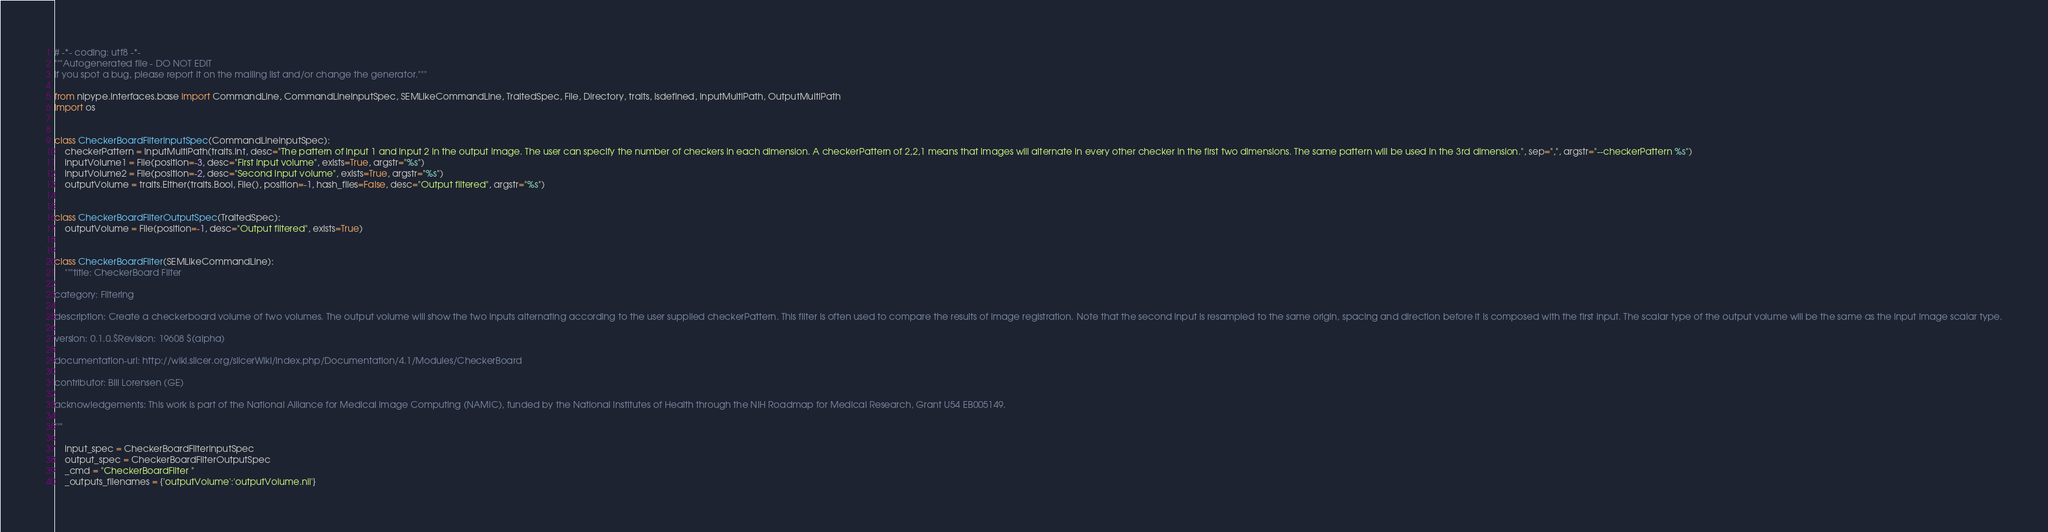<code> <loc_0><loc_0><loc_500><loc_500><_Python_># -*- coding: utf8 -*-
"""Autogenerated file - DO NOT EDIT
If you spot a bug, please report it on the mailing list and/or change the generator."""

from nipype.interfaces.base import CommandLine, CommandLineInputSpec, SEMLikeCommandLine, TraitedSpec, File, Directory, traits, isdefined, InputMultiPath, OutputMultiPath
import os


class CheckerBoardFilterInputSpec(CommandLineInputSpec):
    checkerPattern = InputMultiPath(traits.Int, desc="The pattern of input 1 and input 2 in the output image. The user can specify the number of checkers in each dimension. A checkerPattern of 2,2,1 means that images will alternate in every other checker in the first two dimensions. The same pattern will be used in the 3rd dimension.", sep=",", argstr="--checkerPattern %s")
    inputVolume1 = File(position=-3, desc="First Input volume", exists=True, argstr="%s")
    inputVolume2 = File(position=-2, desc="Second Input volume", exists=True, argstr="%s")
    outputVolume = traits.Either(traits.Bool, File(), position=-1, hash_files=False, desc="Output filtered", argstr="%s")


class CheckerBoardFilterOutputSpec(TraitedSpec):
    outputVolume = File(position=-1, desc="Output filtered", exists=True)


class CheckerBoardFilter(SEMLikeCommandLine):
    """title: CheckerBoard Filter

category: Filtering

description: Create a checkerboard volume of two volumes. The output volume will show the two inputs alternating according to the user supplied checkerPattern. This filter is often used to compare the results of image registration. Note that the second input is resampled to the same origin, spacing and direction before it is composed with the first input. The scalar type of the output volume will be the same as the input image scalar type.

version: 0.1.0.$Revision: 19608 $(alpha)

documentation-url: http://wiki.slicer.org/slicerWiki/index.php/Documentation/4.1/Modules/CheckerBoard

contributor: Bill Lorensen (GE)

acknowledgements: This work is part of the National Alliance for Medical Image Computing (NAMIC), funded by the National Institutes of Health through the NIH Roadmap for Medical Research, Grant U54 EB005149.

"""

    input_spec = CheckerBoardFilterInputSpec
    output_spec = CheckerBoardFilterOutputSpec
    _cmd = "CheckerBoardFilter "
    _outputs_filenames = {'outputVolume':'outputVolume.nii'}
</code> 